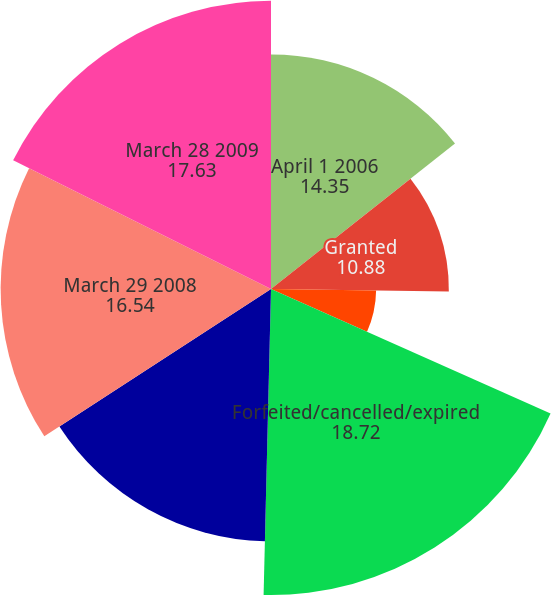<chart> <loc_0><loc_0><loc_500><loc_500><pie_chart><fcel>April 1 2006<fcel>Granted<fcel>Exercised<fcel>Forfeited/cancelled/expired<fcel>March 31 2007<fcel>March 29 2008<fcel>March 28 2009<nl><fcel>14.35%<fcel>10.88%<fcel>6.43%<fcel>18.72%<fcel>15.44%<fcel>16.54%<fcel>17.63%<nl></chart> 